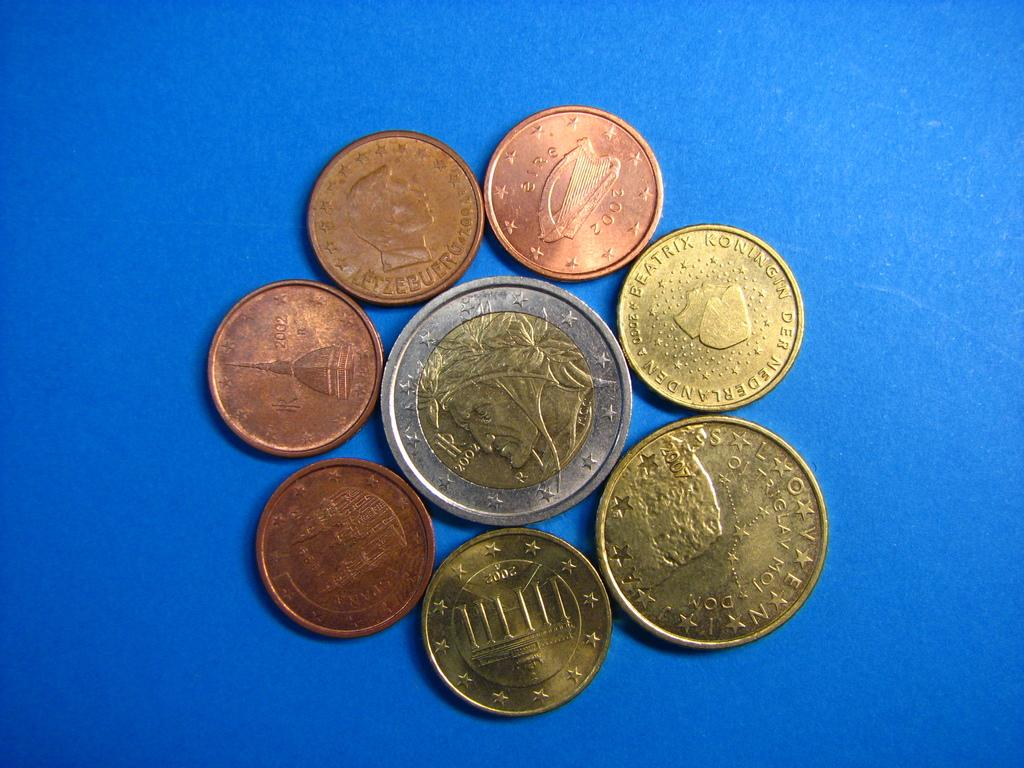<image>
Write a terse but informative summary of the picture. A 2002 series coin rests in the middle of other coins. 